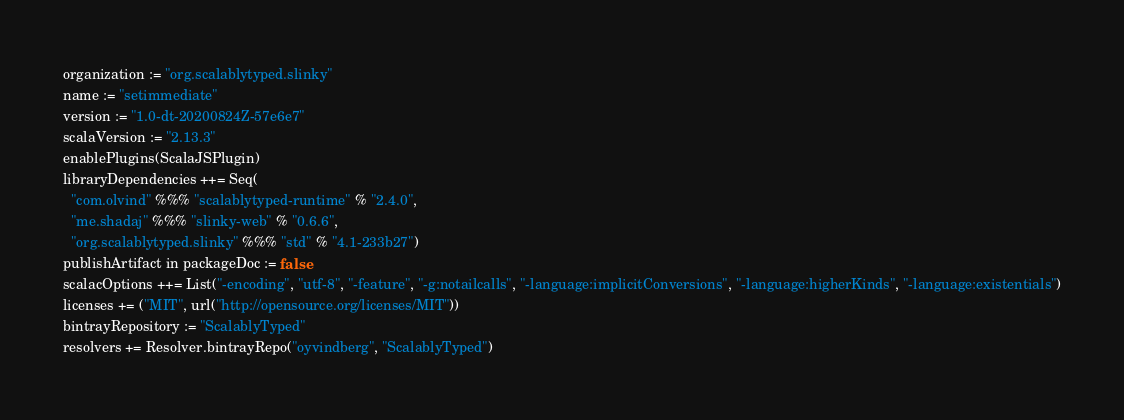<code> <loc_0><loc_0><loc_500><loc_500><_Scala_>organization := "org.scalablytyped.slinky"
name := "setimmediate"
version := "1.0-dt-20200824Z-57e6e7"
scalaVersion := "2.13.3"
enablePlugins(ScalaJSPlugin)
libraryDependencies ++= Seq(
  "com.olvind" %%% "scalablytyped-runtime" % "2.4.0",
  "me.shadaj" %%% "slinky-web" % "0.6.6",
  "org.scalablytyped.slinky" %%% "std" % "4.1-233b27")
publishArtifact in packageDoc := false
scalacOptions ++= List("-encoding", "utf-8", "-feature", "-g:notailcalls", "-language:implicitConversions", "-language:higherKinds", "-language:existentials")
licenses += ("MIT", url("http://opensource.org/licenses/MIT"))
bintrayRepository := "ScalablyTyped"
resolvers += Resolver.bintrayRepo("oyvindberg", "ScalablyTyped")
</code> 